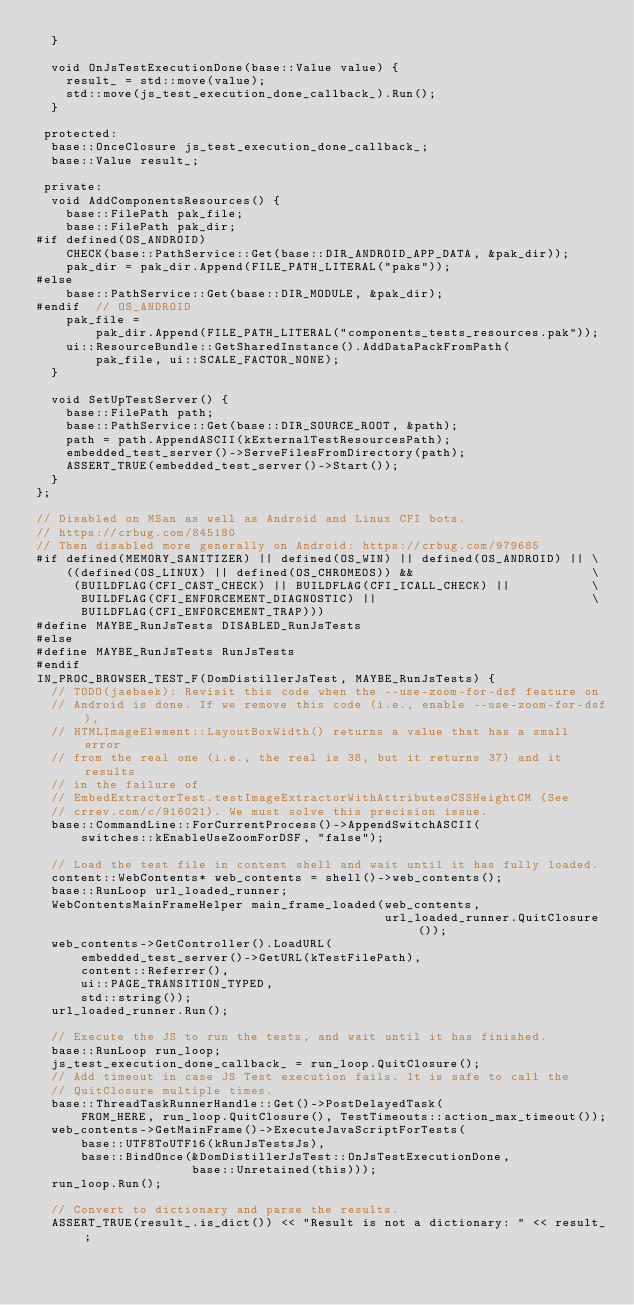Convert code to text. <code><loc_0><loc_0><loc_500><loc_500><_C++_>  }

  void OnJsTestExecutionDone(base::Value value) {
    result_ = std::move(value);
    std::move(js_test_execution_done_callback_).Run();
  }

 protected:
  base::OnceClosure js_test_execution_done_callback_;
  base::Value result_;

 private:
  void AddComponentsResources() {
    base::FilePath pak_file;
    base::FilePath pak_dir;
#if defined(OS_ANDROID)
    CHECK(base::PathService::Get(base::DIR_ANDROID_APP_DATA, &pak_dir));
    pak_dir = pak_dir.Append(FILE_PATH_LITERAL("paks"));
#else
    base::PathService::Get(base::DIR_MODULE, &pak_dir);
#endif  // OS_ANDROID
    pak_file =
        pak_dir.Append(FILE_PATH_LITERAL("components_tests_resources.pak"));
    ui::ResourceBundle::GetSharedInstance().AddDataPackFromPath(
        pak_file, ui::SCALE_FACTOR_NONE);
  }

  void SetUpTestServer() {
    base::FilePath path;
    base::PathService::Get(base::DIR_SOURCE_ROOT, &path);
    path = path.AppendASCII(kExternalTestResourcesPath);
    embedded_test_server()->ServeFilesFromDirectory(path);
    ASSERT_TRUE(embedded_test_server()->Start());
  }
};

// Disabled on MSan as well as Android and Linux CFI bots.
// https://crbug.com/845180
// Then disabled more generally on Android: https://crbug.com/979685
#if defined(MEMORY_SANITIZER) || defined(OS_WIN) || defined(OS_ANDROID) || \
    ((defined(OS_LINUX) || defined(OS_CHROMEOS)) &&                        \
     (BUILDFLAG(CFI_CAST_CHECK) || BUILDFLAG(CFI_ICALL_CHECK) ||           \
      BUILDFLAG(CFI_ENFORCEMENT_DIAGNOSTIC) ||                             \
      BUILDFLAG(CFI_ENFORCEMENT_TRAP)))
#define MAYBE_RunJsTests DISABLED_RunJsTests
#else
#define MAYBE_RunJsTests RunJsTests
#endif
IN_PROC_BROWSER_TEST_F(DomDistillerJsTest, MAYBE_RunJsTests) {
  // TODO(jaebaek): Revisit this code when the --use-zoom-for-dsf feature on
  // Android is done. If we remove this code (i.e., enable --use-zoom-for-dsf),
  // HTMLImageElement::LayoutBoxWidth() returns a value that has a small error
  // from the real one (i.e., the real is 38, but it returns 37) and it results
  // in the failure of
  // EmbedExtractorTest.testImageExtractorWithAttributesCSSHeightCM (See
  // crrev.com/c/916021). We must solve this precision issue.
  base::CommandLine::ForCurrentProcess()->AppendSwitchASCII(
      switches::kEnableUseZoomForDSF, "false");

  // Load the test file in content shell and wait until it has fully loaded.
  content::WebContents* web_contents = shell()->web_contents();
  base::RunLoop url_loaded_runner;
  WebContentsMainFrameHelper main_frame_loaded(web_contents,
                                               url_loaded_runner.QuitClosure());
  web_contents->GetController().LoadURL(
      embedded_test_server()->GetURL(kTestFilePath),
      content::Referrer(),
      ui::PAGE_TRANSITION_TYPED,
      std::string());
  url_loaded_runner.Run();

  // Execute the JS to run the tests, and wait until it has finished.
  base::RunLoop run_loop;
  js_test_execution_done_callback_ = run_loop.QuitClosure();
  // Add timeout in case JS Test execution fails. It is safe to call the
  // QuitClosure multiple times.
  base::ThreadTaskRunnerHandle::Get()->PostDelayedTask(
      FROM_HERE, run_loop.QuitClosure(), TestTimeouts::action_max_timeout());
  web_contents->GetMainFrame()->ExecuteJavaScriptForTests(
      base::UTF8ToUTF16(kRunJsTestsJs),
      base::BindOnce(&DomDistillerJsTest::OnJsTestExecutionDone,
                     base::Unretained(this)));
  run_loop.Run();

  // Convert to dictionary and parse the results.
  ASSERT_TRUE(result_.is_dict()) << "Result is not a dictionary: " << result_;
</code> 